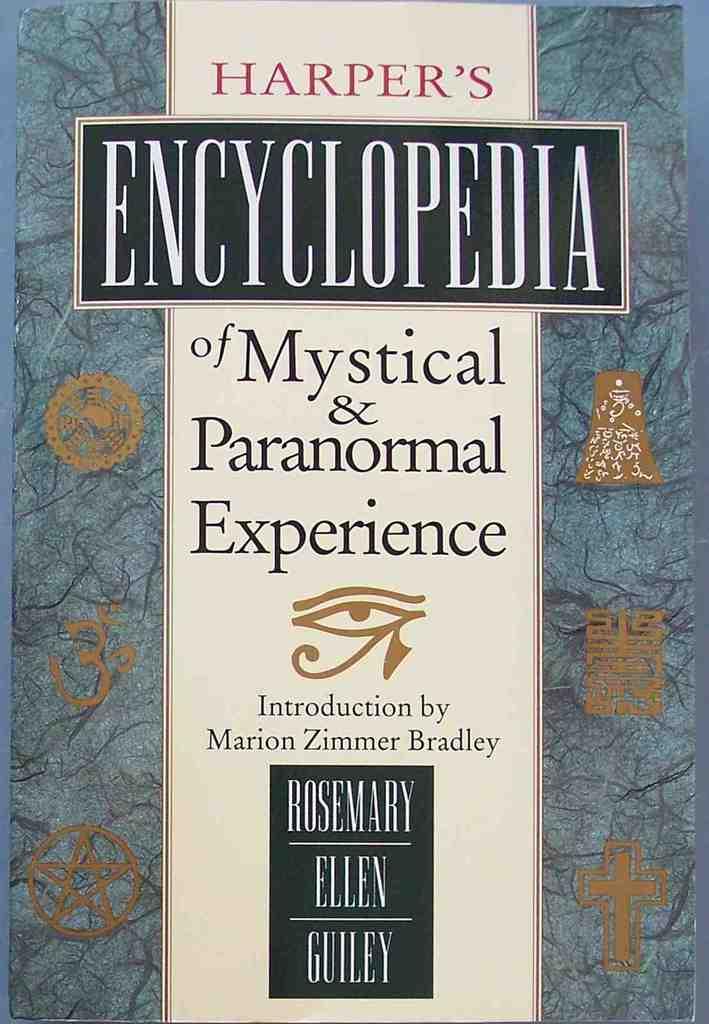What is the book about?
Ensure brevity in your answer.  Mystical and paranormal experience. 